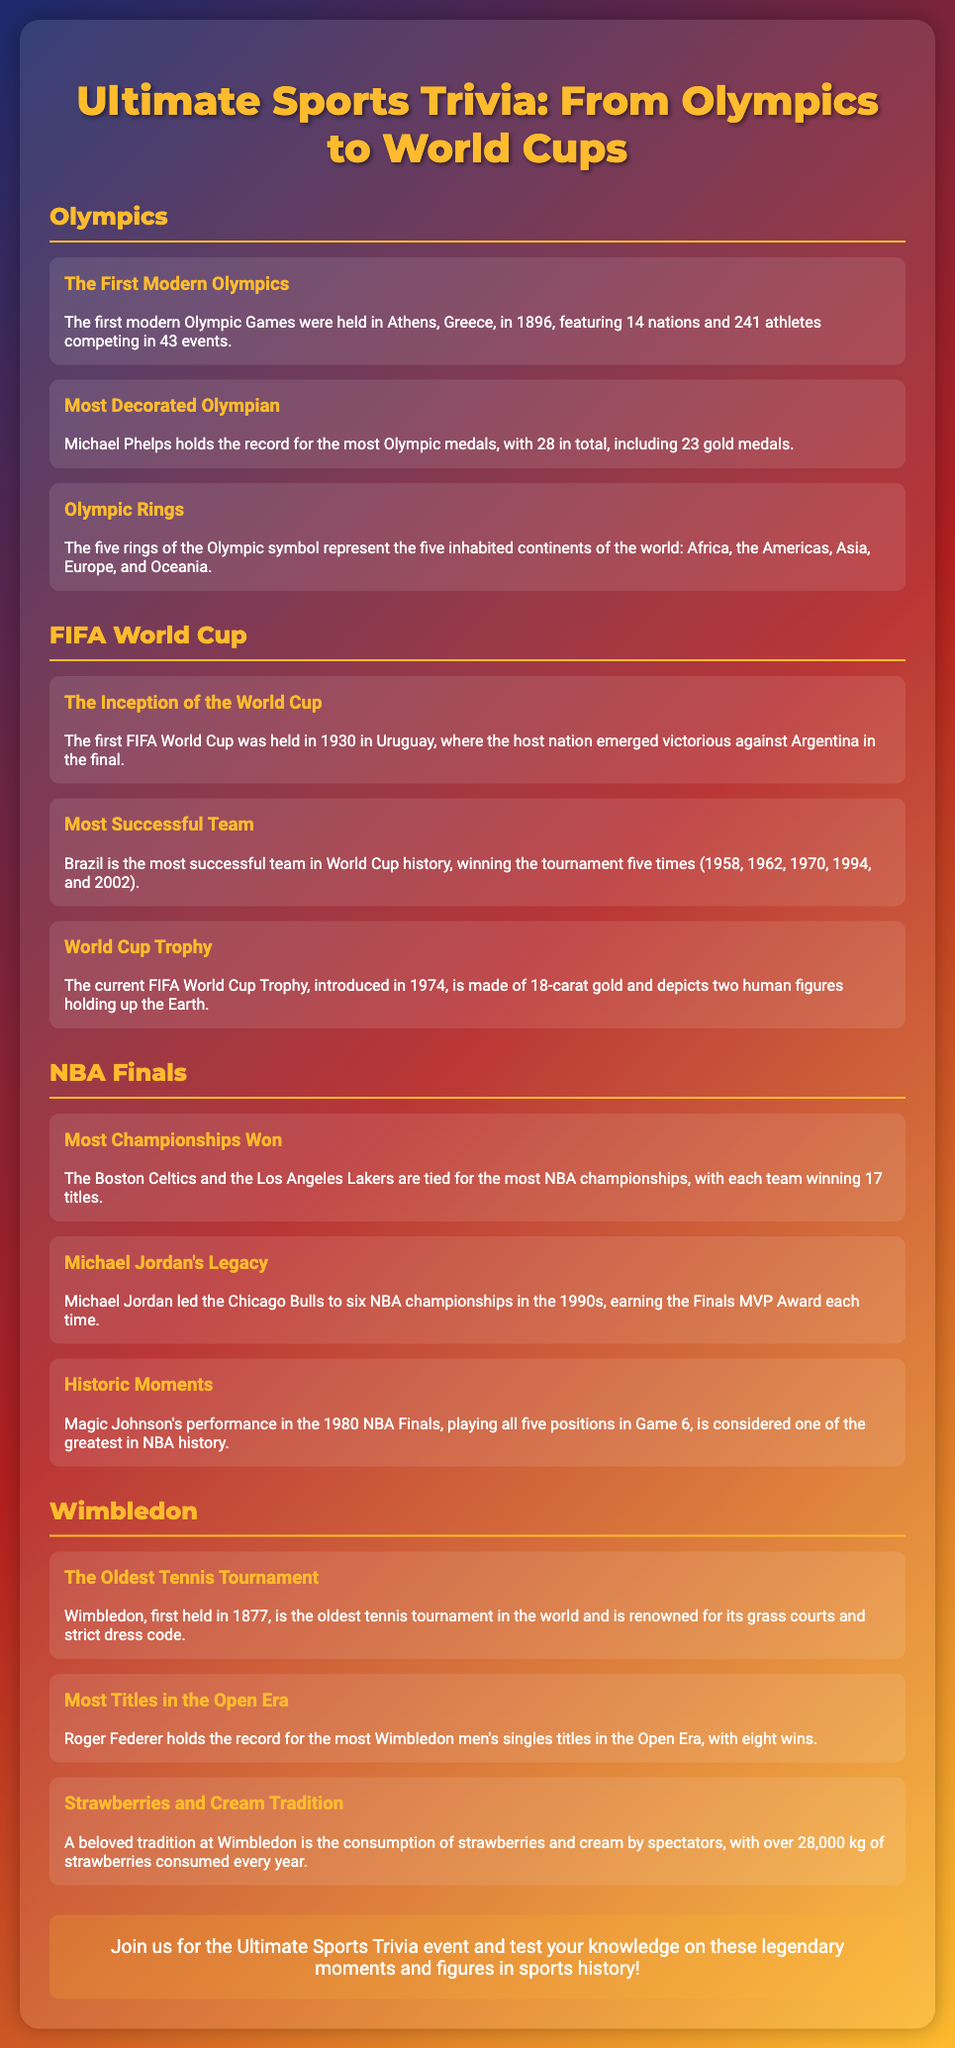What year were the first modern Olympic Games held? The first modern Olympics were held in Athens, Greece, in 1896.
Answer: 1896 How many total Olympic medals does Michael Phelps have? Michael Phelps holds the record with 28 Olympic medals in total.
Answer: 28 Which country won the first FIFA World Cup? The first FIFA World Cup was held in Uruguay, where the host nation won against Argentina.
Answer: Uruguay How many times has Brazil won the FIFA World Cup? Brazil is the most successful team with five World Cup victories.
Answer: Five Who is tied with the most NBA championships? The Boston Celtics and the Los Angeles Lakers are tied for the most NBA championships.
Answer: Boston Celtics and Los Angeles Lakers How many NBA championships did Michael Jordan win? Michael Jordan led the Chicago Bulls to six NBA championships.
Answer: Six When was the first Wimbledon tournament held? Wimbledon was first held in 1877.
Answer: 1877 Who holds the record for most Wimbledon men's singles titles in the Open Era? Roger Federer holds the record with eight Wimbledon men's singles titles.
Answer: Roger Federer What is a popular tradition at Wimbledon? A beloved tradition at Wimbledon is the consumption of strawberries and cream by spectators.
Answer: Strawberries and cream 